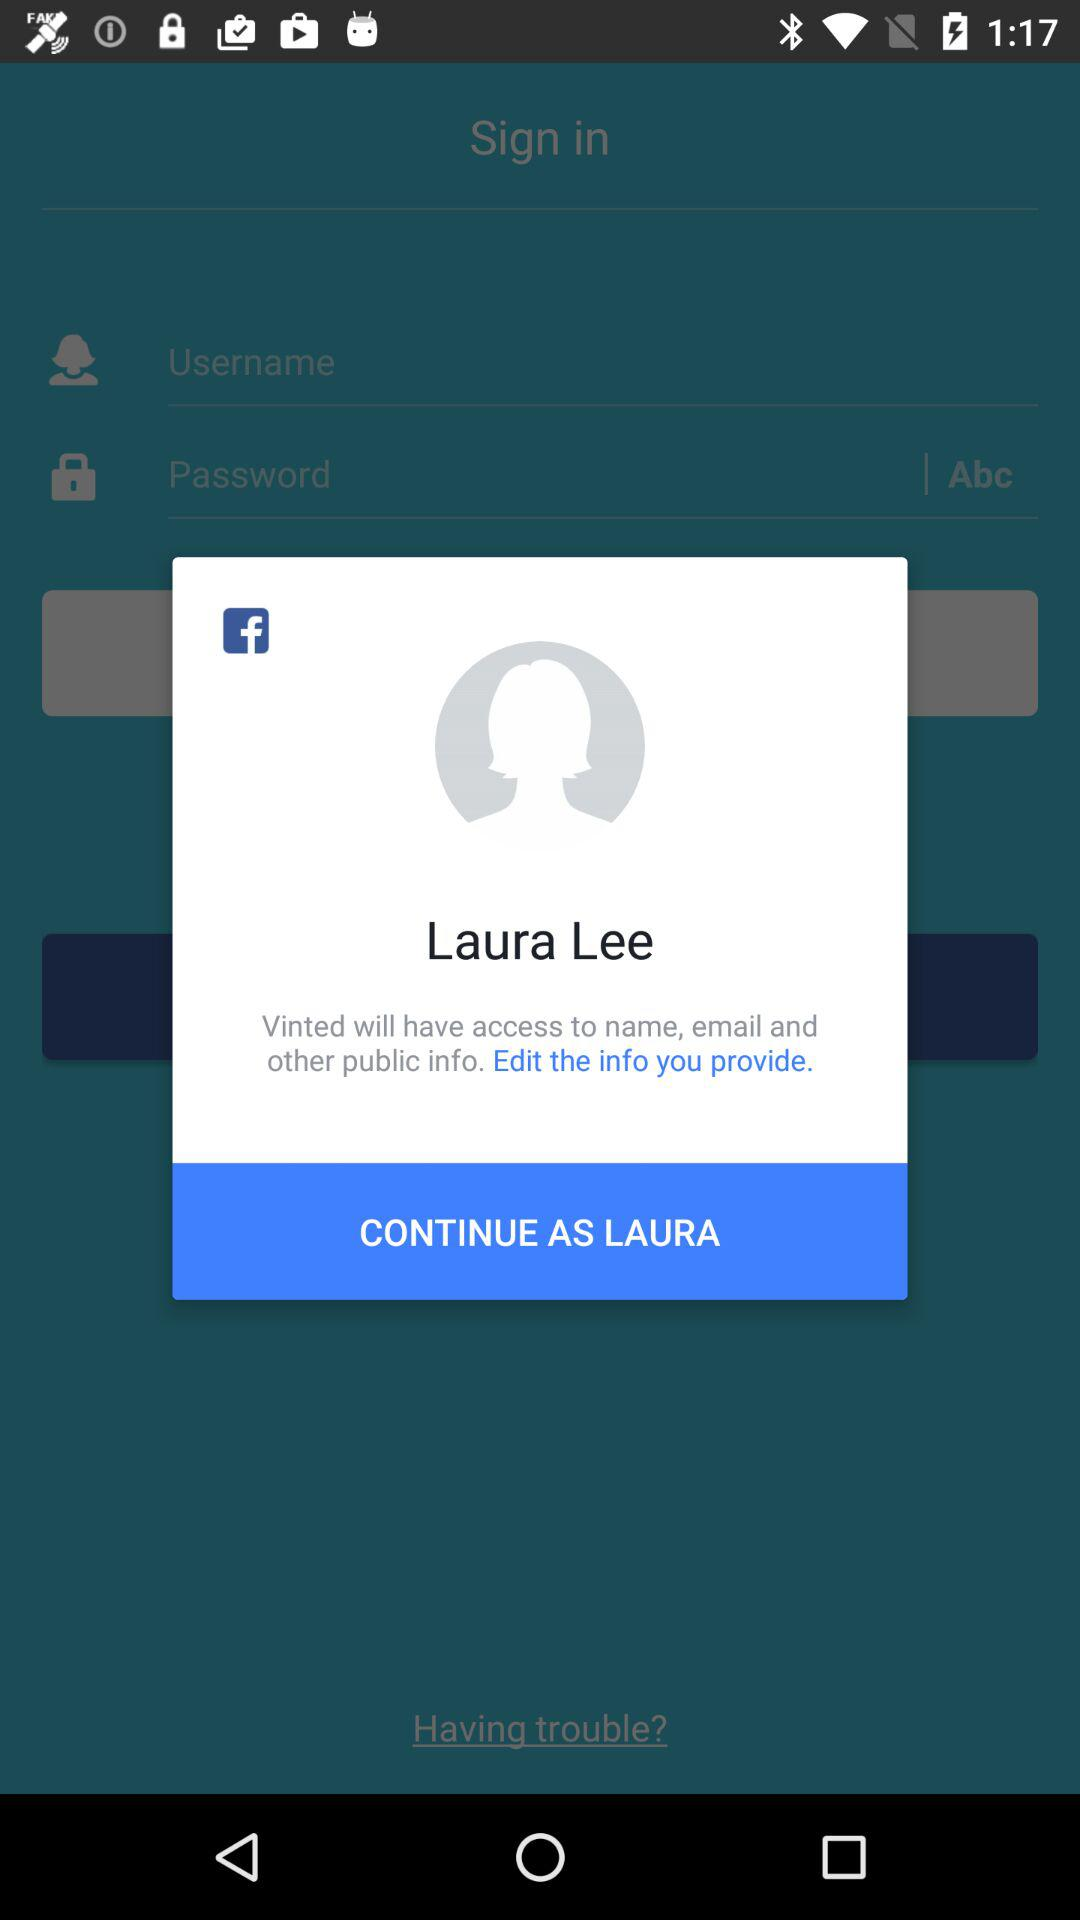What is the name of the user? The name of the user is Laura Lee. 